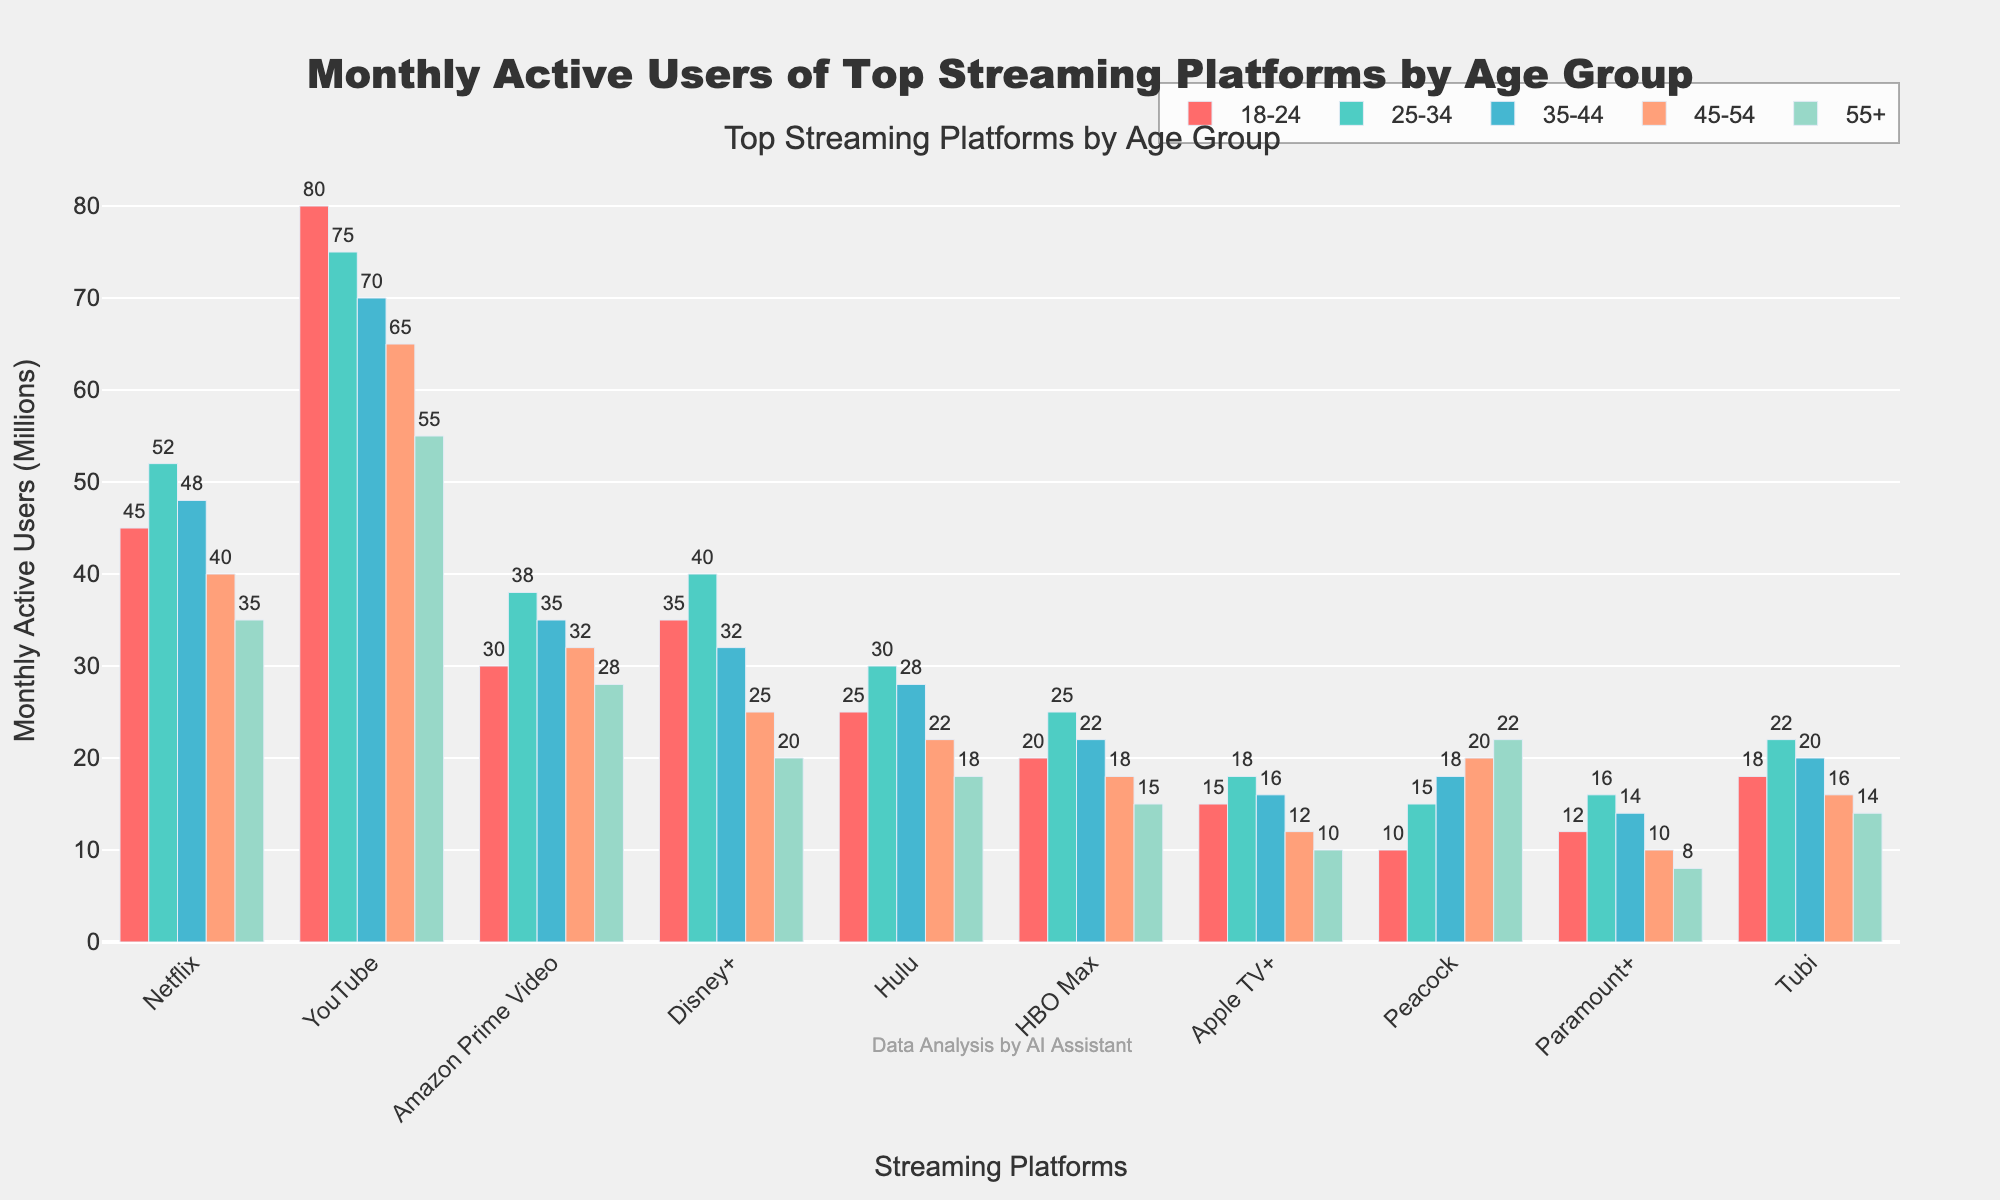Which streaming platform has the highest number of monthly active users in the 18-24 age group? The highest bar in the 18-24 age group corresponds to YouTube. Therefore, YouTube has the highest number of monthly active users in the 18-24 age group.
Answer: YouTube Which platform has more users in the 25-34 age group, Netflix or Amazon Prime Video? In the 25-34 age group, Netflix has 52 million users, whereas Amazon Prime Video has 38 million users. Comparing these values, Netflix has more users in this age group.
Answer: Netflix What is the total number of monthly active users for Disney+ across all age groups? Sum the number of users for Disney+ across all age groups: 35 (18-24) + 40 (25-34) + 32 (35-44) + 25 (45-54) + 20 (55+) = 152 million.
Answer: 152 million In the 45-54 age group, which platform has the fewest number of monthly active users? The bars show that Apple TV+ has the fewest number of users for the 45-54 age group, with 12 million users.
Answer: Apple TV+ Is the number of monthly active users aged 55+ for YouTube greater than the combined number of users aged 55+ for Hulu and HBO Max? YouTube has 55 million users aged 55+. Hulu has 18 million and HBO Max has 15 million in the same age group. Combined, Hulu and HBO Max have 18 + 15 = 33 million users. 55 million (YouTube) is greater than 33 million.
Answer: Yes How does the number of monthly active users of Tubi in the 35-44 age group compare to that of Paramount+ in the same age group? Tubi has 20 million users in the 35-44 age group, while Paramount+ has 14 million users. Since 20 million is greater than 14 million, Tubi has more users in this age group compared to Paramount+.
Answer: Tubi Compare the total number of monthly active users for Hulu and HBO Max in the 18-24 age group. Hulu has 25 million users and HBO Max has 20 million users in the 18-24 age group. Adding these up, Hulu has more users than HBO Max in this group. The individual totals are 25 million (Hulu) and 20 million (HBO Max).
Answer: Hulu Which streaming platform shows a decreasing trend in monthly active users as age increases? Observing the bars, Disney+ shows a clear decreasing trend: 35 (18-24), 40 (25-34), 32 (35-44), 25 (45-54), 20 (55+). The trend decreases consistently as age increases except between 18-24 and 25-34 where there is a slight increase.
Answer: Disney+ 